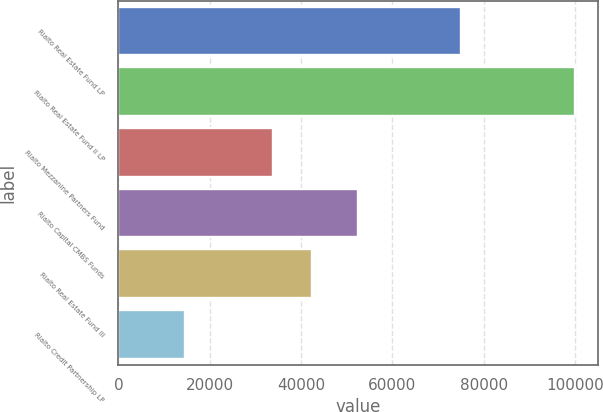<chart> <loc_0><loc_0><loc_500><loc_500><bar_chart><fcel>Rialto Real Estate Fund LP<fcel>Rialto Real Estate Fund II LP<fcel>Rialto Mezzanine Partners Fund<fcel>Rialto Capital CMBS Funds<fcel>Rialto Real Estate Fund III<fcel>Rialto Credit Partnership LP<nl><fcel>75000<fcel>100000<fcel>33799<fcel>52474<fcel>42345.6<fcel>14534<nl></chart> 